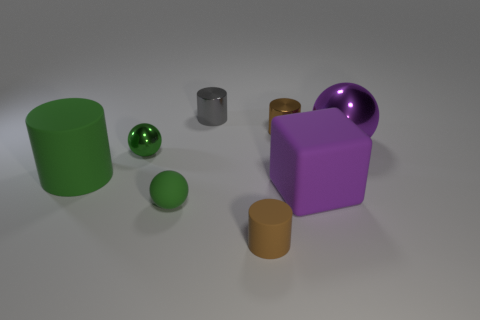Subtract all brown spheres. How many brown cylinders are left? 2 Subtract all green cylinders. How many cylinders are left? 3 Subtract all small cylinders. How many cylinders are left? 1 Add 1 brown matte things. How many objects exist? 9 Subtract 2 cylinders. How many cylinders are left? 2 Subtract all red cylinders. Subtract all gray cubes. How many cylinders are left? 4 Subtract all blocks. How many objects are left? 7 Subtract all cubes. Subtract all big rubber cylinders. How many objects are left? 6 Add 5 big purple shiny objects. How many big purple shiny objects are left? 6 Add 7 tiny brown rubber objects. How many tiny brown rubber objects exist? 8 